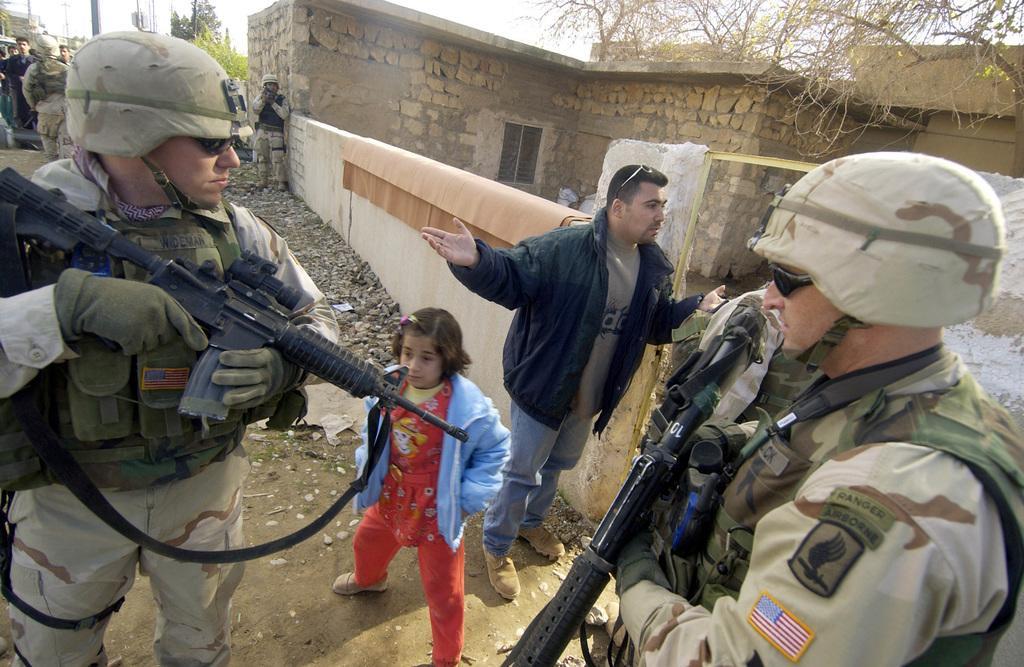How would you summarize this image in a sentence or two? In the image we can see there are people wearing clothes and we can see a few people wearing army clothes, caps, gloves and holding rifle in the hands. Here we can see a child, house, trees, pole and the sky. 